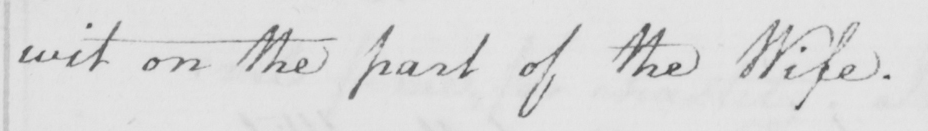What does this handwritten line say? wit on the part of the Wife . 